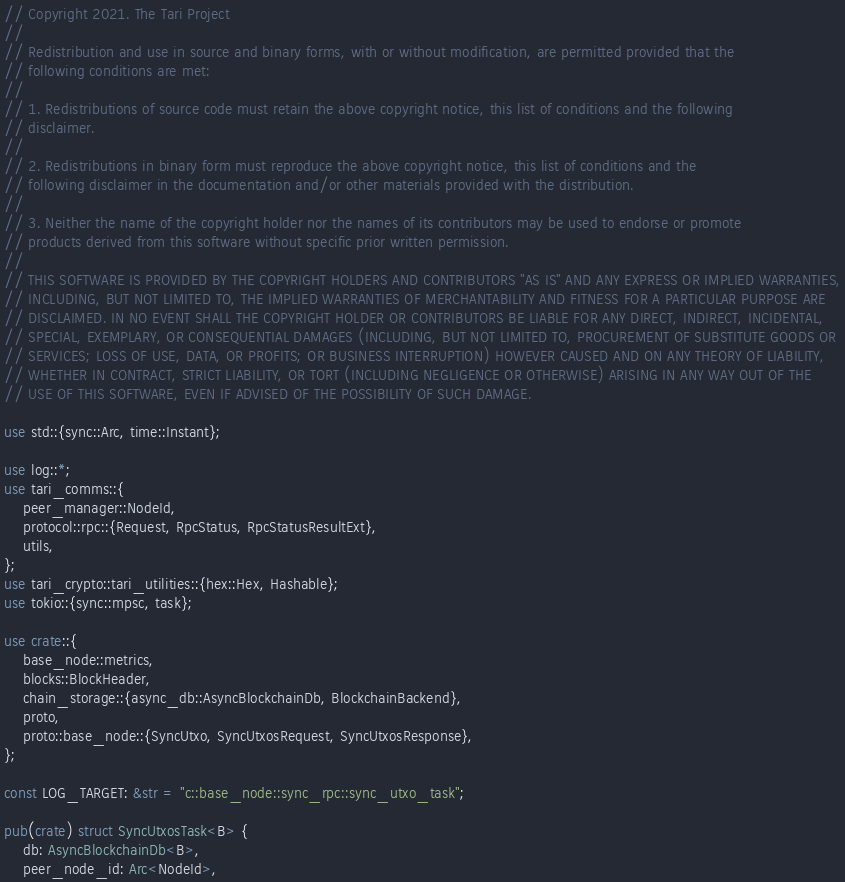Convert code to text. <code><loc_0><loc_0><loc_500><loc_500><_Rust_>// Copyright 2021. The Tari Project
//
// Redistribution and use in source and binary forms, with or without modification, are permitted provided that the
// following conditions are met:
//
// 1. Redistributions of source code must retain the above copyright notice, this list of conditions and the following
// disclaimer.
//
// 2. Redistributions in binary form must reproduce the above copyright notice, this list of conditions and the
// following disclaimer in the documentation and/or other materials provided with the distribution.
//
// 3. Neither the name of the copyright holder nor the names of its contributors may be used to endorse or promote
// products derived from this software without specific prior written permission.
//
// THIS SOFTWARE IS PROVIDED BY THE COPYRIGHT HOLDERS AND CONTRIBUTORS "AS IS" AND ANY EXPRESS OR IMPLIED WARRANTIES,
// INCLUDING, BUT NOT LIMITED TO, THE IMPLIED WARRANTIES OF MERCHANTABILITY AND FITNESS FOR A PARTICULAR PURPOSE ARE
// DISCLAIMED. IN NO EVENT SHALL THE COPYRIGHT HOLDER OR CONTRIBUTORS BE LIABLE FOR ANY DIRECT, INDIRECT, INCIDENTAL,
// SPECIAL, EXEMPLARY, OR CONSEQUENTIAL DAMAGES (INCLUDING, BUT NOT LIMITED TO, PROCUREMENT OF SUBSTITUTE GOODS OR
// SERVICES; LOSS OF USE, DATA, OR PROFITS; OR BUSINESS INTERRUPTION) HOWEVER CAUSED AND ON ANY THEORY OF LIABILITY,
// WHETHER IN CONTRACT, STRICT LIABILITY, OR TORT (INCLUDING NEGLIGENCE OR OTHERWISE) ARISING IN ANY WAY OUT OF THE
// USE OF THIS SOFTWARE, EVEN IF ADVISED OF THE POSSIBILITY OF SUCH DAMAGE.

use std::{sync::Arc, time::Instant};

use log::*;
use tari_comms::{
    peer_manager::NodeId,
    protocol::rpc::{Request, RpcStatus, RpcStatusResultExt},
    utils,
};
use tari_crypto::tari_utilities::{hex::Hex, Hashable};
use tokio::{sync::mpsc, task};

use crate::{
    base_node::metrics,
    blocks::BlockHeader,
    chain_storage::{async_db::AsyncBlockchainDb, BlockchainBackend},
    proto,
    proto::base_node::{SyncUtxo, SyncUtxosRequest, SyncUtxosResponse},
};

const LOG_TARGET: &str = "c::base_node::sync_rpc::sync_utxo_task";

pub(crate) struct SyncUtxosTask<B> {
    db: AsyncBlockchainDb<B>,
    peer_node_id: Arc<NodeId>,</code> 